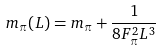Convert formula to latex. <formula><loc_0><loc_0><loc_500><loc_500>m _ { \pi } ( L ) = m _ { \pi } + \frac { 1 } { 8 F _ { \pi } ^ { 2 } L ^ { 3 } }</formula> 